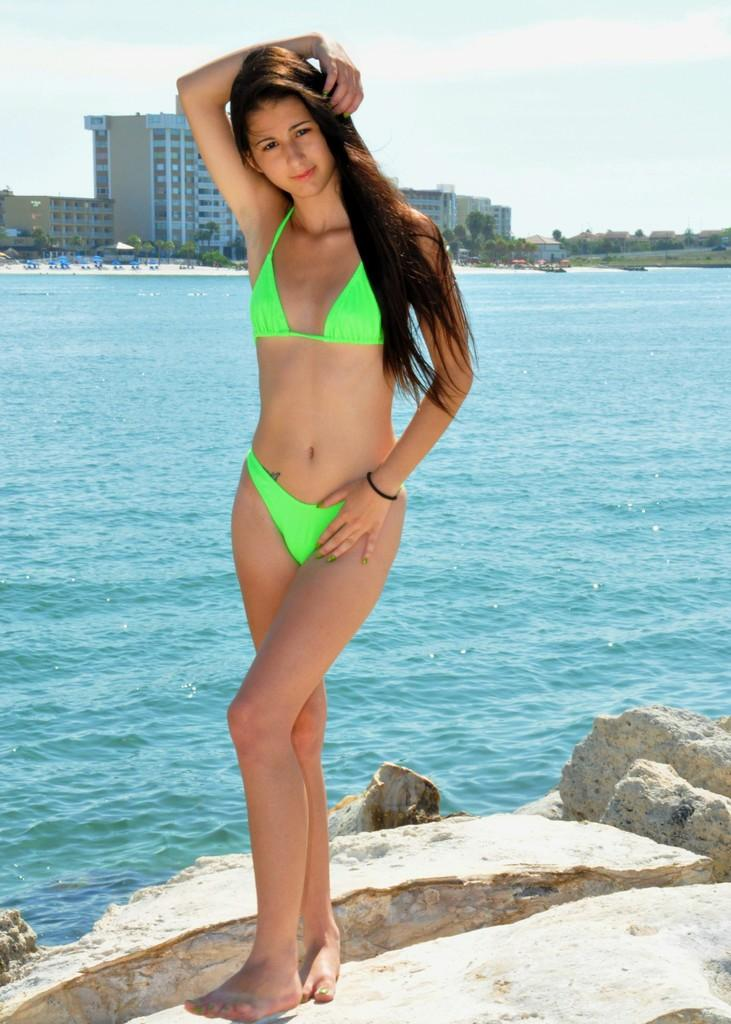What is the main subject of the image? There is a woman standing in the image. What type of natural elements can be seen in the image? Rocks and water are visible in the image. What can be seen in the background of the image? There are buildings, trees, and the sky visible in the background of the image. What type of tooth is visible in the image? There is no tooth present in the image. Is there a cushion being used by the woman in the image? There is no cushion visible in the image. 